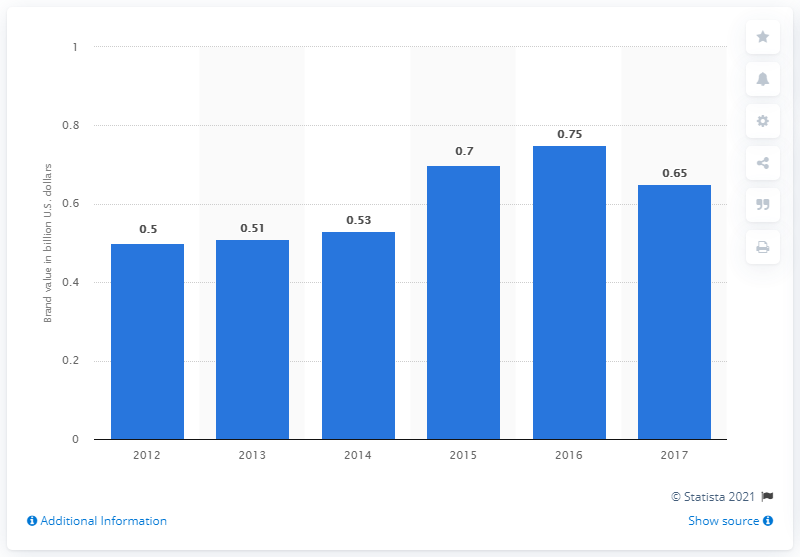Specify some key components in this picture. NESN's brand value in dollars in 2017 was approximately $0.65. The average of the first three years is 0.513. The graph represents approximately 6 years. 